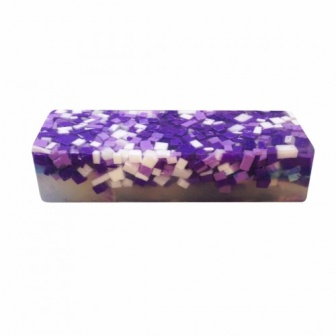Let's say this soap has magical properties. What could these properties be? In an enchanting twist, this soap could possess magical properties that grant the user a sense of calm and clarity once used. Each purple tile could release calming lavender scents that soothe the mind, while the white tiles might have an invigorating effect, awakening and energizing the senses. Additionally, this soap could have the unique ability to change color according to the user's mood, giving visual feedback that could aid in emotional awareness and balance. What do you think happens if you use this magical soap under a full moon? Under the light of a full moon, this magical soap could unleash its most potent abilities. It might emit a soft, luminescent glow, enhancing the bathing experience with a serene, mystic ambiance. The aromatic properties could intensify, drawing out any stress or negativity and replacing it with positivity and inner peace. Bathing with this soap under a full moon could also heighten one's intuition and creativity, making for an almost ritualistic experience that refreshes the body, mind, and spirit. 